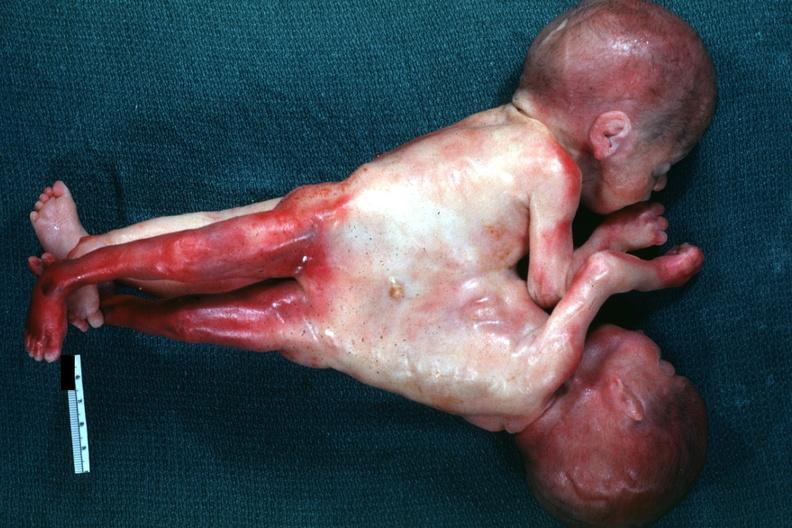s mesentery joined abdomen and lower chest anterior?
Answer the question using a single word or phrase. No 